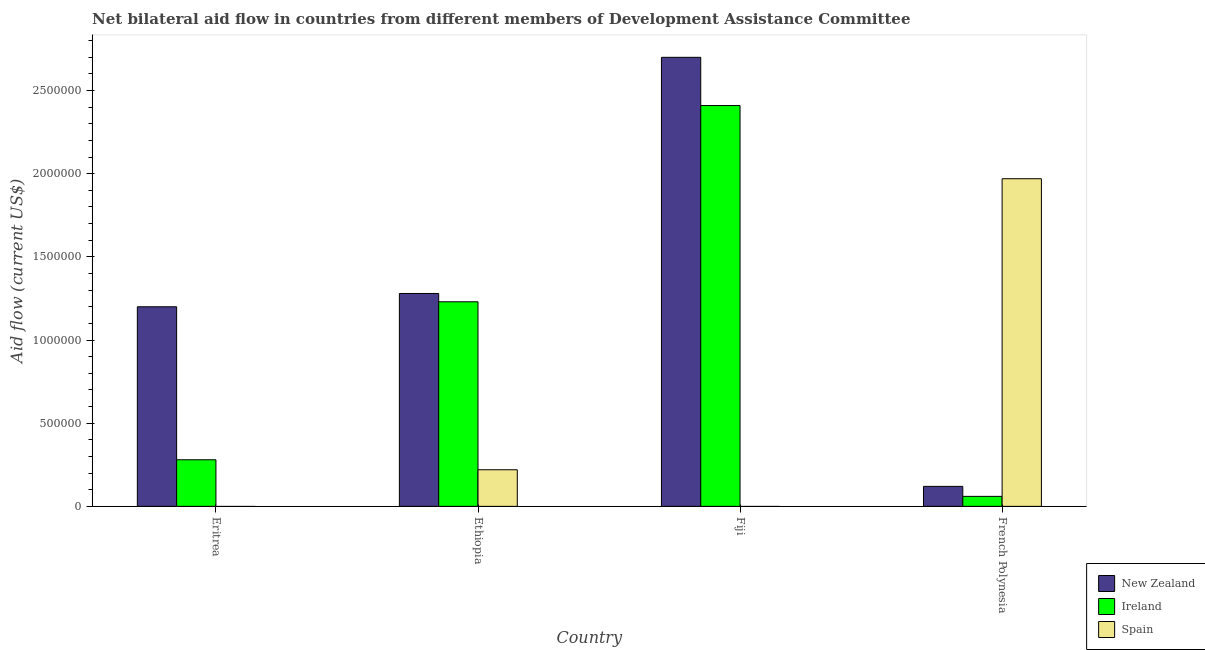How many different coloured bars are there?
Your answer should be very brief. 3. How many groups of bars are there?
Your answer should be very brief. 4. Are the number of bars per tick equal to the number of legend labels?
Give a very brief answer. No. Are the number of bars on each tick of the X-axis equal?
Offer a very short reply. No. How many bars are there on the 3rd tick from the left?
Ensure brevity in your answer.  2. How many bars are there on the 3rd tick from the right?
Ensure brevity in your answer.  3. What is the label of the 4th group of bars from the left?
Provide a short and direct response. French Polynesia. In how many cases, is the number of bars for a given country not equal to the number of legend labels?
Ensure brevity in your answer.  2. What is the amount of aid provided by new zealand in Ethiopia?
Your response must be concise. 1.28e+06. Across all countries, what is the maximum amount of aid provided by new zealand?
Offer a very short reply. 2.70e+06. Across all countries, what is the minimum amount of aid provided by spain?
Keep it short and to the point. 0. In which country was the amount of aid provided by ireland maximum?
Your answer should be very brief. Fiji. What is the total amount of aid provided by spain in the graph?
Ensure brevity in your answer.  2.19e+06. What is the difference between the amount of aid provided by new zealand in Eritrea and that in French Polynesia?
Your answer should be compact. 1.08e+06. What is the difference between the amount of aid provided by ireland in Fiji and the amount of aid provided by spain in French Polynesia?
Provide a succinct answer. 4.40e+05. What is the average amount of aid provided by ireland per country?
Offer a very short reply. 9.95e+05. What is the difference between the amount of aid provided by spain and amount of aid provided by ireland in French Polynesia?
Your response must be concise. 1.91e+06. What is the ratio of the amount of aid provided by ireland in Eritrea to that in French Polynesia?
Offer a very short reply. 4.67. What is the difference between the highest and the second highest amount of aid provided by ireland?
Your answer should be compact. 1.18e+06. What is the difference between the highest and the lowest amount of aid provided by new zealand?
Keep it short and to the point. 2.58e+06. In how many countries, is the amount of aid provided by ireland greater than the average amount of aid provided by ireland taken over all countries?
Make the answer very short. 2. How many countries are there in the graph?
Your answer should be very brief. 4. What is the difference between two consecutive major ticks on the Y-axis?
Provide a succinct answer. 5.00e+05. Does the graph contain any zero values?
Your answer should be compact. Yes. Where does the legend appear in the graph?
Your answer should be compact. Bottom right. How many legend labels are there?
Your answer should be very brief. 3. What is the title of the graph?
Your answer should be very brief. Net bilateral aid flow in countries from different members of Development Assistance Committee. What is the Aid flow (current US$) of New Zealand in Eritrea?
Provide a short and direct response. 1.20e+06. What is the Aid flow (current US$) of New Zealand in Ethiopia?
Give a very brief answer. 1.28e+06. What is the Aid flow (current US$) in Ireland in Ethiopia?
Offer a very short reply. 1.23e+06. What is the Aid flow (current US$) of New Zealand in Fiji?
Offer a very short reply. 2.70e+06. What is the Aid flow (current US$) in Ireland in Fiji?
Offer a terse response. 2.41e+06. What is the Aid flow (current US$) of New Zealand in French Polynesia?
Make the answer very short. 1.20e+05. What is the Aid flow (current US$) of Ireland in French Polynesia?
Your answer should be very brief. 6.00e+04. What is the Aid flow (current US$) of Spain in French Polynesia?
Your answer should be very brief. 1.97e+06. Across all countries, what is the maximum Aid flow (current US$) in New Zealand?
Provide a succinct answer. 2.70e+06. Across all countries, what is the maximum Aid flow (current US$) in Ireland?
Your response must be concise. 2.41e+06. Across all countries, what is the maximum Aid flow (current US$) in Spain?
Make the answer very short. 1.97e+06. What is the total Aid flow (current US$) of New Zealand in the graph?
Make the answer very short. 5.30e+06. What is the total Aid flow (current US$) of Ireland in the graph?
Provide a succinct answer. 3.98e+06. What is the total Aid flow (current US$) of Spain in the graph?
Keep it short and to the point. 2.19e+06. What is the difference between the Aid flow (current US$) of New Zealand in Eritrea and that in Ethiopia?
Provide a short and direct response. -8.00e+04. What is the difference between the Aid flow (current US$) in Ireland in Eritrea and that in Ethiopia?
Your answer should be very brief. -9.50e+05. What is the difference between the Aid flow (current US$) in New Zealand in Eritrea and that in Fiji?
Give a very brief answer. -1.50e+06. What is the difference between the Aid flow (current US$) of Ireland in Eritrea and that in Fiji?
Your answer should be compact. -2.13e+06. What is the difference between the Aid flow (current US$) in New Zealand in Eritrea and that in French Polynesia?
Provide a succinct answer. 1.08e+06. What is the difference between the Aid flow (current US$) in Ireland in Eritrea and that in French Polynesia?
Ensure brevity in your answer.  2.20e+05. What is the difference between the Aid flow (current US$) in New Zealand in Ethiopia and that in Fiji?
Offer a terse response. -1.42e+06. What is the difference between the Aid flow (current US$) of Ireland in Ethiopia and that in Fiji?
Offer a very short reply. -1.18e+06. What is the difference between the Aid flow (current US$) of New Zealand in Ethiopia and that in French Polynesia?
Give a very brief answer. 1.16e+06. What is the difference between the Aid flow (current US$) in Ireland in Ethiopia and that in French Polynesia?
Your response must be concise. 1.17e+06. What is the difference between the Aid flow (current US$) of Spain in Ethiopia and that in French Polynesia?
Ensure brevity in your answer.  -1.75e+06. What is the difference between the Aid flow (current US$) of New Zealand in Fiji and that in French Polynesia?
Your answer should be very brief. 2.58e+06. What is the difference between the Aid flow (current US$) of Ireland in Fiji and that in French Polynesia?
Offer a very short reply. 2.35e+06. What is the difference between the Aid flow (current US$) in New Zealand in Eritrea and the Aid flow (current US$) in Spain in Ethiopia?
Keep it short and to the point. 9.80e+05. What is the difference between the Aid flow (current US$) of New Zealand in Eritrea and the Aid flow (current US$) of Ireland in Fiji?
Give a very brief answer. -1.21e+06. What is the difference between the Aid flow (current US$) in New Zealand in Eritrea and the Aid flow (current US$) in Ireland in French Polynesia?
Offer a very short reply. 1.14e+06. What is the difference between the Aid flow (current US$) in New Zealand in Eritrea and the Aid flow (current US$) in Spain in French Polynesia?
Keep it short and to the point. -7.70e+05. What is the difference between the Aid flow (current US$) in Ireland in Eritrea and the Aid flow (current US$) in Spain in French Polynesia?
Keep it short and to the point. -1.69e+06. What is the difference between the Aid flow (current US$) of New Zealand in Ethiopia and the Aid flow (current US$) of Ireland in Fiji?
Offer a very short reply. -1.13e+06. What is the difference between the Aid flow (current US$) in New Zealand in Ethiopia and the Aid flow (current US$) in Ireland in French Polynesia?
Your response must be concise. 1.22e+06. What is the difference between the Aid flow (current US$) in New Zealand in Ethiopia and the Aid flow (current US$) in Spain in French Polynesia?
Your answer should be very brief. -6.90e+05. What is the difference between the Aid flow (current US$) of Ireland in Ethiopia and the Aid flow (current US$) of Spain in French Polynesia?
Make the answer very short. -7.40e+05. What is the difference between the Aid flow (current US$) of New Zealand in Fiji and the Aid flow (current US$) of Ireland in French Polynesia?
Offer a terse response. 2.64e+06. What is the difference between the Aid flow (current US$) of New Zealand in Fiji and the Aid flow (current US$) of Spain in French Polynesia?
Offer a terse response. 7.30e+05. What is the average Aid flow (current US$) in New Zealand per country?
Your answer should be compact. 1.32e+06. What is the average Aid flow (current US$) of Ireland per country?
Keep it short and to the point. 9.95e+05. What is the average Aid flow (current US$) in Spain per country?
Your answer should be very brief. 5.48e+05. What is the difference between the Aid flow (current US$) of New Zealand and Aid flow (current US$) of Ireland in Eritrea?
Provide a succinct answer. 9.20e+05. What is the difference between the Aid flow (current US$) of New Zealand and Aid flow (current US$) of Spain in Ethiopia?
Make the answer very short. 1.06e+06. What is the difference between the Aid flow (current US$) in Ireland and Aid flow (current US$) in Spain in Ethiopia?
Provide a succinct answer. 1.01e+06. What is the difference between the Aid flow (current US$) of New Zealand and Aid flow (current US$) of Ireland in French Polynesia?
Offer a terse response. 6.00e+04. What is the difference between the Aid flow (current US$) in New Zealand and Aid flow (current US$) in Spain in French Polynesia?
Your answer should be very brief. -1.85e+06. What is the difference between the Aid flow (current US$) of Ireland and Aid flow (current US$) of Spain in French Polynesia?
Offer a terse response. -1.91e+06. What is the ratio of the Aid flow (current US$) of Ireland in Eritrea to that in Ethiopia?
Offer a very short reply. 0.23. What is the ratio of the Aid flow (current US$) in New Zealand in Eritrea to that in Fiji?
Give a very brief answer. 0.44. What is the ratio of the Aid flow (current US$) of Ireland in Eritrea to that in Fiji?
Make the answer very short. 0.12. What is the ratio of the Aid flow (current US$) of New Zealand in Eritrea to that in French Polynesia?
Your answer should be compact. 10. What is the ratio of the Aid flow (current US$) in Ireland in Eritrea to that in French Polynesia?
Your answer should be compact. 4.67. What is the ratio of the Aid flow (current US$) in New Zealand in Ethiopia to that in Fiji?
Offer a very short reply. 0.47. What is the ratio of the Aid flow (current US$) in Ireland in Ethiopia to that in Fiji?
Keep it short and to the point. 0.51. What is the ratio of the Aid flow (current US$) in New Zealand in Ethiopia to that in French Polynesia?
Ensure brevity in your answer.  10.67. What is the ratio of the Aid flow (current US$) of Spain in Ethiopia to that in French Polynesia?
Make the answer very short. 0.11. What is the ratio of the Aid flow (current US$) of New Zealand in Fiji to that in French Polynesia?
Your answer should be compact. 22.5. What is the ratio of the Aid flow (current US$) in Ireland in Fiji to that in French Polynesia?
Give a very brief answer. 40.17. What is the difference between the highest and the second highest Aid flow (current US$) in New Zealand?
Ensure brevity in your answer.  1.42e+06. What is the difference between the highest and the second highest Aid flow (current US$) of Ireland?
Keep it short and to the point. 1.18e+06. What is the difference between the highest and the lowest Aid flow (current US$) of New Zealand?
Your response must be concise. 2.58e+06. What is the difference between the highest and the lowest Aid flow (current US$) of Ireland?
Ensure brevity in your answer.  2.35e+06. What is the difference between the highest and the lowest Aid flow (current US$) in Spain?
Your answer should be compact. 1.97e+06. 